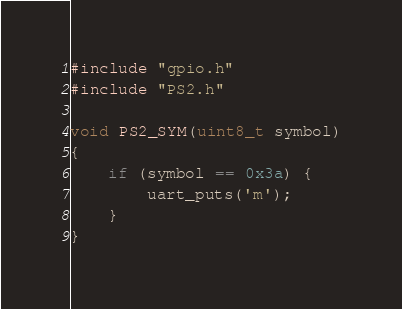Convert code to text. <code><loc_0><loc_0><loc_500><loc_500><_C_>#include "gpio.h"
#include "PS2.h"

void PS2_SYM(uint8_t symbol)
{
    if (symbol == 0x3a) {
        uart_puts('m');
    }
}</code> 